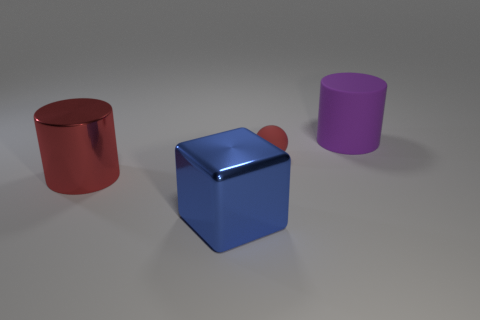Add 2 tiny matte things. How many objects exist? 6 Subtract 1 cubes. How many cubes are left? 0 Subtract all purple cylinders. Subtract all cyan spheres. How many cylinders are left? 1 Subtract all large red metal objects. Subtract all large green rubber cubes. How many objects are left? 3 Add 4 red rubber balls. How many red rubber balls are left? 5 Add 1 yellow rubber spheres. How many yellow rubber spheres exist? 1 Subtract all purple cylinders. How many cylinders are left? 1 Subtract 0 green blocks. How many objects are left? 4 Subtract all spheres. How many objects are left? 3 